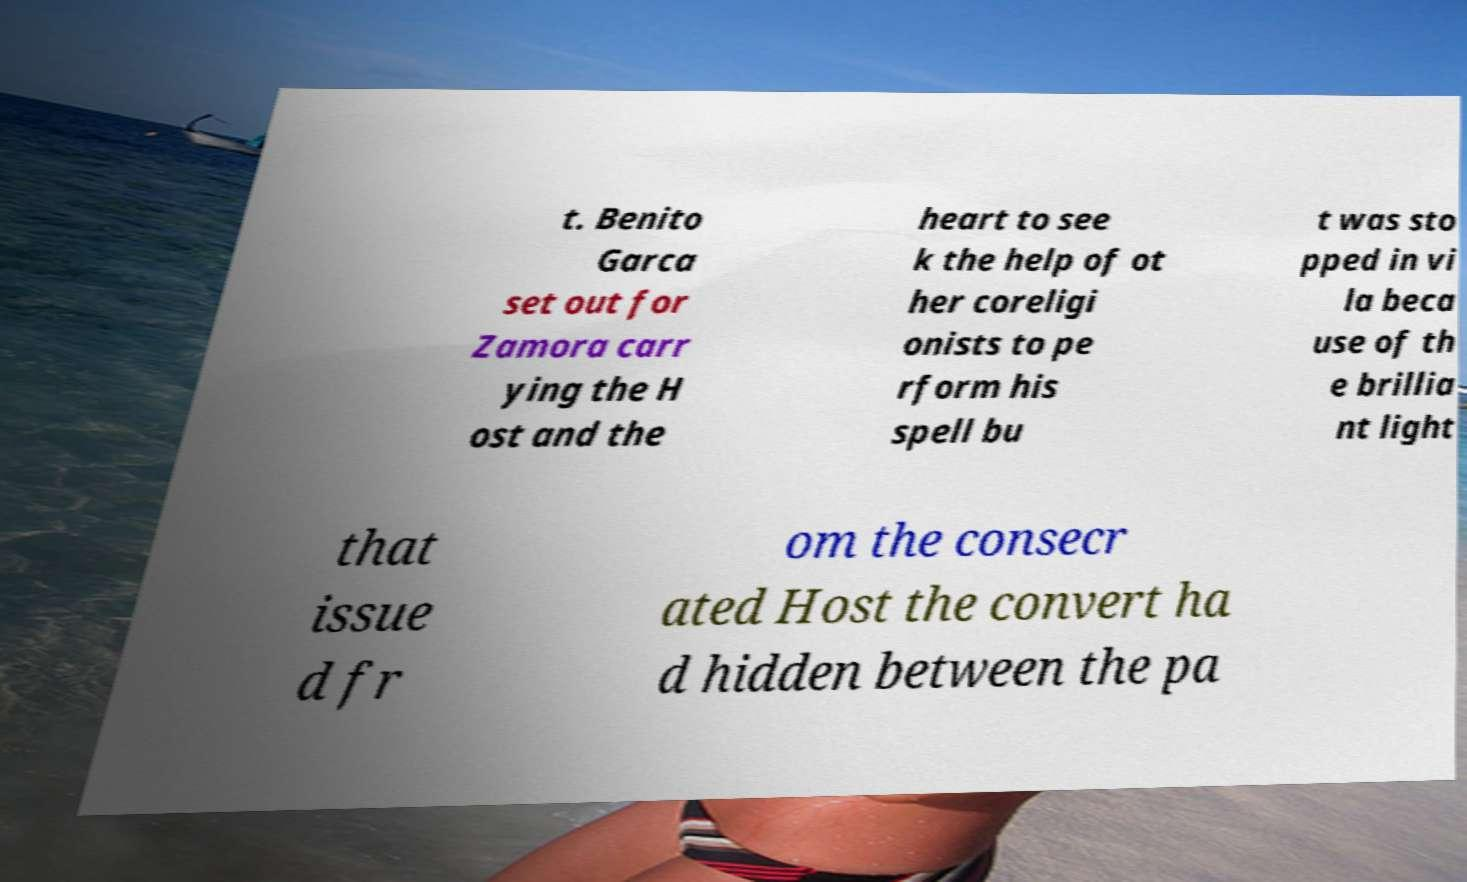There's text embedded in this image that I need extracted. Can you transcribe it verbatim? t. Benito Garca set out for Zamora carr ying the H ost and the heart to see k the help of ot her coreligi onists to pe rform his spell bu t was sto pped in vi la beca use of th e brillia nt light that issue d fr om the consecr ated Host the convert ha d hidden between the pa 